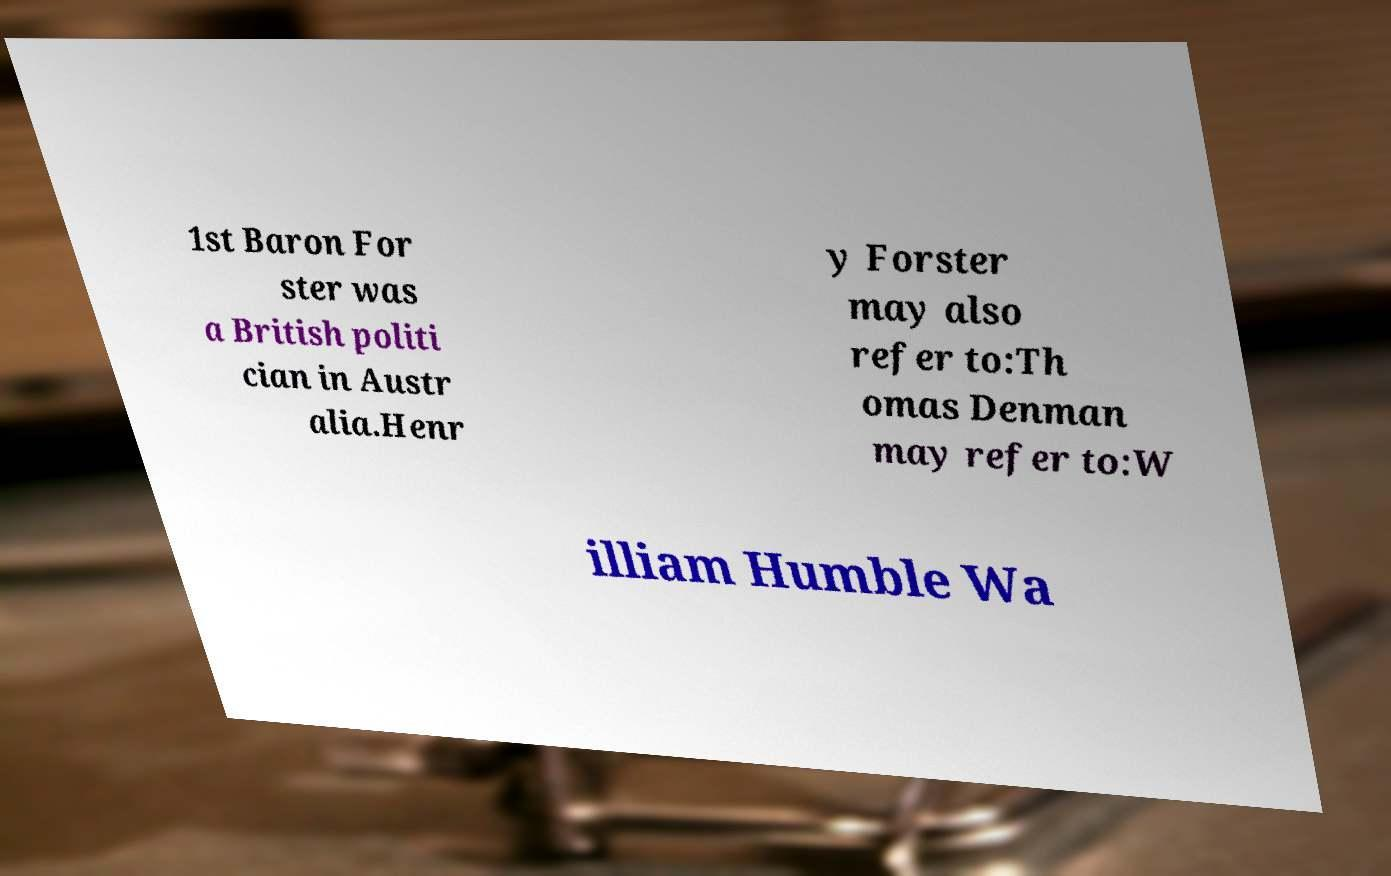Could you assist in decoding the text presented in this image and type it out clearly? 1st Baron For ster was a British politi cian in Austr alia.Henr y Forster may also refer to:Th omas Denman may refer to:W illiam Humble Wa 